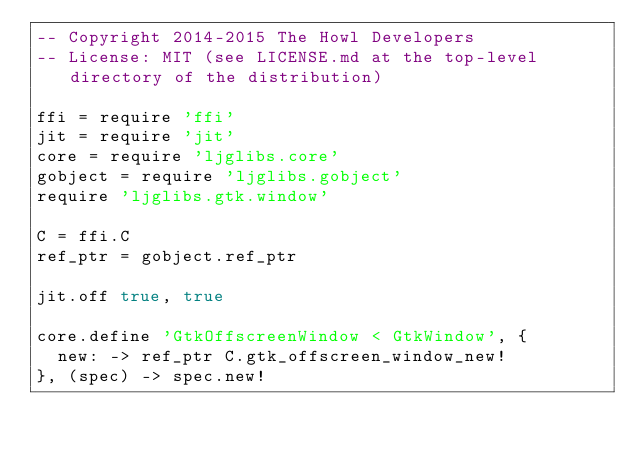<code> <loc_0><loc_0><loc_500><loc_500><_MoonScript_>-- Copyright 2014-2015 The Howl Developers
-- License: MIT (see LICENSE.md at the top-level directory of the distribution)

ffi = require 'ffi'
jit = require 'jit'
core = require 'ljglibs.core'
gobject = require 'ljglibs.gobject'
require 'ljglibs.gtk.window'

C = ffi.C
ref_ptr = gobject.ref_ptr

jit.off true, true

core.define 'GtkOffscreenWindow < GtkWindow', {
  new: -> ref_ptr C.gtk_offscreen_window_new!
}, (spec) -> spec.new!
</code> 